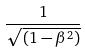Convert formula to latex. <formula><loc_0><loc_0><loc_500><loc_500>\frac { 1 } { \sqrt { ( 1 - \beta ^ { 2 } ) } }</formula> 